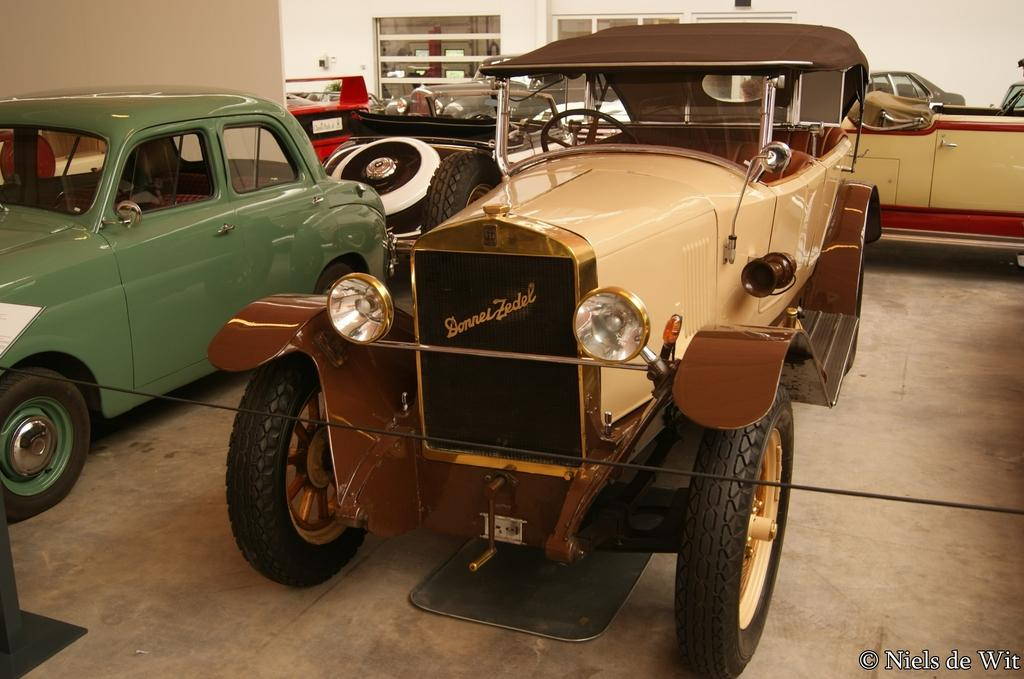What is located in the center of the image? There are vehicles and a wire in the center of the image. What can be seen at the top of the image? There is a wall, cupboards, and other objects at the top of the image. What is the surface on which the vehicles and wire are placed? There is a floor at the bottom of the image. How many rings are visible on the vehicles in the image? There is no mention of rings in the image, so it is impossible to determine their presence or quantity. What type of hammer is being used to work on the wall in the image? There is no hammer present in the image; only vehicles, a wire, a wall, cupboards, and other objects are visible. 